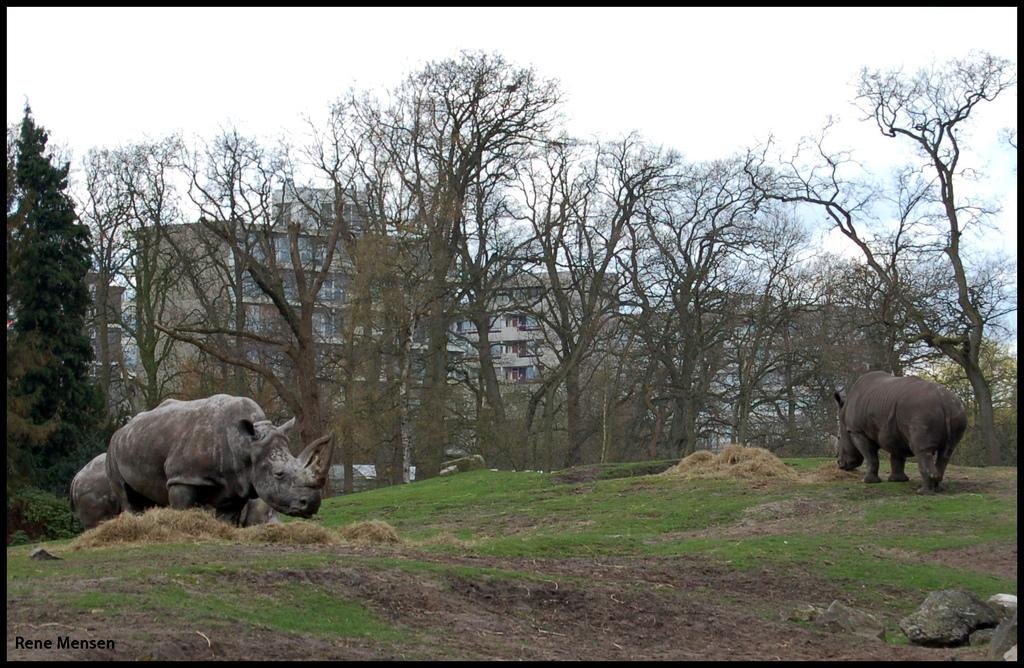What animals are on the ground in the image? There are rhinos on the ground in the image. What object can be seen on the right side of the image? There is a stone on the right side of the image. What type of vegetation is visible in the background of the image? There are trees in the background of the image. What type of structures can be seen in the background of the image? There are buildings in the background of the image. What part of the natural environment is visible in the image? The sky is visible in the background of the image. What color is the horse's blood in the image? There is no horse or blood present in the image. 